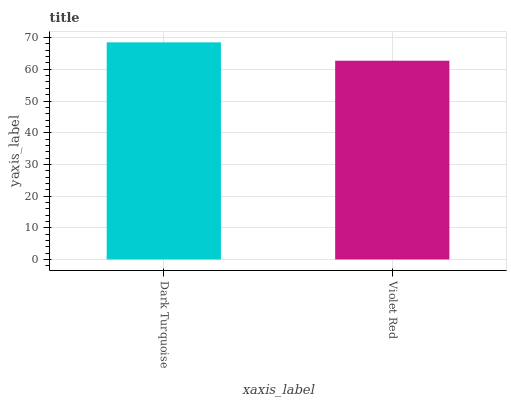Is Violet Red the minimum?
Answer yes or no. Yes. Is Dark Turquoise the maximum?
Answer yes or no. Yes. Is Violet Red the maximum?
Answer yes or no. No. Is Dark Turquoise greater than Violet Red?
Answer yes or no. Yes. Is Violet Red less than Dark Turquoise?
Answer yes or no. Yes. Is Violet Red greater than Dark Turquoise?
Answer yes or no. No. Is Dark Turquoise less than Violet Red?
Answer yes or no. No. Is Dark Turquoise the high median?
Answer yes or no. Yes. Is Violet Red the low median?
Answer yes or no. Yes. Is Violet Red the high median?
Answer yes or no. No. Is Dark Turquoise the low median?
Answer yes or no. No. 